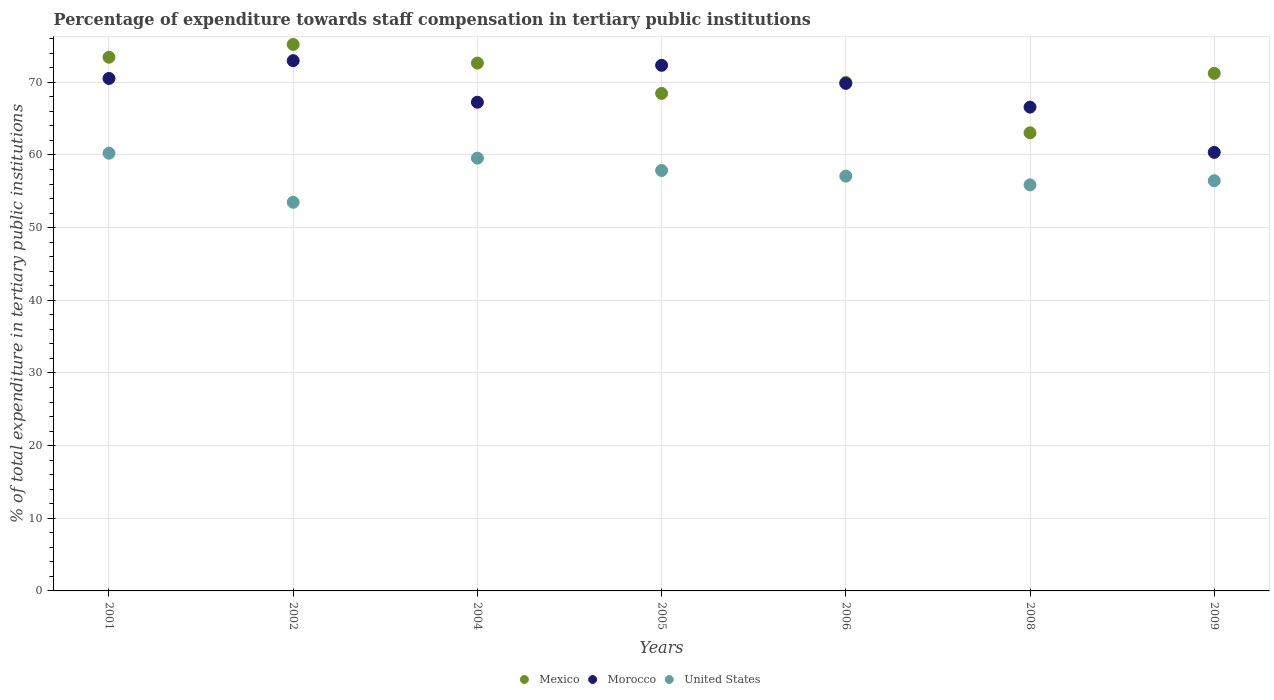What is the percentage of expenditure towards staff compensation in United States in 2009?
Your answer should be very brief. 56.46. Across all years, what is the maximum percentage of expenditure towards staff compensation in Mexico?
Offer a very short reply. 75.21. Across all years, what is the minimum percentage of expenditure towards staff compensation in United States?
Give a very brief answer. 53.49. What is the total percentage of expenditure towards staff compensation in Morocco in the graph?
Offer a terse response. 479.9. What is the difference between the percentage of expenditure towards staff compensation in United States in 2005 and that in 2006?
Make the answer very short. 0.78. What is the difference between the percentage of expenditure towards staff compensation in Mexico in 2002 and the percentage of expenditure towards staff compensation in United States in 2001?
Your answer should be very brief. 14.97. What is the average percentage of expenditure towards staff compensation in Mexico per year?
Keep it short and to the point. 70.58. In the year 2001, what is the difference between the percentage of expenditure towards staff compensation in United States and percentage of expenditure towards staff compensation in Mexico?
Make the answer very short. -13.21. In how many years, is the percentage of expenditure towards staff compensation in Mexico greater than 50 %?
Your answer should be compact. 7. What is the ratio of the percentage of expenditure towards staff compensation in Morocco in 2004 to that in 2008?
Offer a very short reply. 1.01. What is the difference between the highest and the second highest percentage of expenditure towards staff compensation in Morocco?
Provide a short and direct response. 0.64. What is the difference between the highest and the lowest percentage of expenditure towards staff compensation in United States?
Offer a terse response. 6.75. In how many years, is the percentage of expenditure towards staff compensation in Mexico greater than the average percentage of expenditure towards staff compensation in Mexico taken over all years?
Your answer should be very brief. 4. Is it the case that in every year, the sum of the percentage of expenditure towards staff compensation in United States and percentage of expenditure towards staff compensation in Mexico  is greater than the percentage of expenditure towards staff compensation in Morocco?
Your answer should be compact. Yes. Does the percentage of expenditure towards staff compensation in Morocco monotonically increase over the years?
Ensure brevity in your answer.  No. How many dotlines are there?
Keep it short and to the point. 3. How many years are there in the graph?
Provide a short and direct response. 7. Does the graph contain any zero values?
Ensure brevity in your answer.  No. Does the graph contain grids?
Provide a short and direct response. Yes. How many legend labels are there?
Provide a succinct answer. 3. What is the title of the graph?
Give a very brief answer. Percentage of expenditure towards staff compensation in tertiary public institutions. What is the label or title of the X-axis?
Make the answer very short. Years. What is the label or title of the Y-axis?
Keep it short and to the point. % of total expenditure in tertiary public institutions. What is the % of total expenditure in tertiary public institutions in Mexico in 2001?
Provide a short and direct response. 73.45. What is the % of total expenditure in tertiary public institutions of Morocco in 2001?
Provide a short and direct response. 70.53. What is the % of total expenditure in tertiary public institutions in United States in 2001?
Offer a very short reply. 60.24. What is the % of total expenditure in tertiary public institutions of Mexico in 2002?
Offer a terse response. 75.21. What is the % of total expenditure in tertiary public institutions in Morocco in 2002?
Ensure brevity in your answer.  72.98. What is the % of total expenditure in tertiary public institutions in United States in 2002?
Your answer should be compact. 53.49. What is the % of total expenditure in tertiary public institutions of Mexico in 2004?
Offer a terse response. 72.65. What is the % of total expenditure in tertiary public institutions in Morocco in 2004?
Ensure brevity in your answer.  67.26. What is the % of total expenditure in tertiary public institutions of United States in 2004?
Your answer should be compact. 59.56. What is the % of total expenditure in tertiary public institutions of Mexico in 2005?
Offer a terse response. 68.47. What is the % of total expenditure in tertiary public institutions of Morocco in 2005?
Provide a short and direct response. 72.34. What is the % of total expenditure in tertiary public institutions in United States in 2005?
Your response must be concise. 57.86. What is the % of total expenditure in tertiary public institutions of Mexico in 2006?
Ensure brevity in your answer.  69.98. What is the % of total expenditure in tertiary public institutions of Morocco in 2006?
Offer a very short reply. 69.85. What is the % of total expenditure in tertiary public institutions in United States in 2006?
Offer a terse response. 57.09. What is the % of total expenditure in tertiary public institutions of Mexico in 2008?
Offer a terse response. 63.05. What is the % of total expenditure in tertiary public institutions of Morocco in 2008?
Provide a short and direct response. 66.59. What is the % of total expenditure in tertiary public institutions in United States in 2008?
Make the answer very short. 55.88. What is the % of total expenditure in tertiary public institutions of Mexico in 2009?
Make the answer very short. 71.23. What is the % of total expenditure in tertiary public institutions in Morocco in 2009?
Your answer should be very brief. 60.36. What is the % of total expenditure in tertiary public institutions of United States in 2009?
Provide a succinct answer. 56.46. Across all years, what is the maximum % of total expenditure in tertiary public institutions of Mexico?
Offer a very short reply. 75.21. Across all years, what is the maximum % of total expenditure in tertiary public institutions in Morocco?
Your response must be concise. 72.98. Across all years, what is the maximum % of total expenditure in tertiary public institutions of United States?
Your answer should be very brief. 60.24. Across all years, what is the minimum % of total expenditure in tertiary public institutions in Mexico?
Give a very brief answer. 63.05. Across all years, what is the minimum % of total expenditure in tertiary public institutions of Morocco?
Your response must be concise. 60.36. Across all years, what is the minimum % of total expenditure in tertiary public institutions in United States?
Offer a very short reply. 53.49. What is the total % of total expenditure in tertiary public institutions of Mexico in the graph?
Make the answer very short. 494.05. What is the total % of total expenditure in tertiary public institutions of Morocco in the graph?
Your answer should be very brief. 479.9. What is the total % of total expenditure in tertiary public institutions of United States in the graph?
Your answer should be compact. 400.59. What is the difference between the % of total expenditure in tertiary public institutions of Mexico in 2001 and that in 2002?
Ensure brevity in your answer.  -1.76. What is the difference between the % of total expenditure in tertiary public institutions in Morocco in 2001 and that in 2002?
Keep it short and to the point. -2.45. What is the difference between the % of total expenditure in tertiary public institutions in United States in 2001 and that in 2002?
Offer a very short reply. 6.75. What is the difference between the % of total expenditure in tertiary public institutions in Mexico in 2001 and that in 2004?
Give a very brief answer. 0.81. What is the difference between the % of total expenditure in tertiary public institutions in Morocco in 2001 and that in 2004?
Your answer should be very brief. 3.27. What is the difference between the % of total expenditure in tertiary public institutions in United States in 2001 and that in 2004?
Keep it short and to the point. 0.68. What is the difference between the % of total expenditure in tertiary public institutions of Mexico in 2001 and that in 2005?
Your answer should be compact. 4.98. What is the difference between the % of total expenditure in tertiary public institutions in Morocco in 2001 and that in 2005?
Offer a terse response. -1.81. What is the difference between the % of total expenditure in tertiary public institutions in United States in 2001 and that in 2005?
Offer a very short reply. 2.38. What is the difference between the % of total expenditure in tertiary public institutions in Mexico in 2001 and that in 2006?
Your answer should be very brief. 3.47. What is the difference between the % of total expenditure in tertiary public institutions in Morocco in 2001 and that in 2006?
Your answer should be compact. 0.68. What is the difference between the % of total expenditure in tertiary public institutions of United States in 2001 and that in 2006?
Give a very brief answer. 3.15. What is the difference between the % of total expenditure in tertiary public institutions in Mexico in 2001 and that in 2008?
Make the answer very short. 10.4. What is the difference between the % of total expenditure in tertiary public institutions of Morocco in 2001 and that in 2008?
Provide a short and direct response. 3.95. What is the difference between the % of total expenditure in tertiary public institutions of United States in 2001 and that in 2008?
Keep it short and to the point. 4.36. What is the difference between the % of total expenditure in tertiary public institutions in Mexico in 2001 and that in 2009?
Your answer should be compact. 2.22. What is the difference between the % of total expenditure in tertiary public institutions in Morocco in 2001 and that in 2009?
Give a very brief answer. 10.18. What is the difference between the % of total expenditure in tertiary public institutions of United States in 2001 and that in 2009?
Provide a short and direct response. 3.79. What is the difference between the % of total expenditure in tertiary public institutions in Mexico in 2002 and that in 2004?
Your answer should be very brief. 2.56. What is the difference between the % of total expenditure in tertiary public institutions of Morocco in 2002 and that in 2004?
Offer a very short reply. 5.72. What is the difference between the % of total expenditure in tertiary public institutions in United States in 2002 and that in 2004?
Ensure brevity in your answer.  -6.07. What is the difference between the % of total expenditure in tertiary public institutions in Mexico in 2002 and that in 2005?
Your answer should be very brief. 6.74. What is the difference between the % of total expenditure in tertiary public institutions in Morocco in 2002 and that in 2005?
Your response must be concise. 0.64. What is the difference between the % of total expenditure in tertiary public institutions of United States in 2002 and that in 2005?
Give a very brief answer. -4.37. What is the difference between the % of total expenditure in tertiary public institutions in Mexico in 2002 and that in 2006?
Provide a succinct answer. 5.23. What is the difference between the % of total expenditure in tertiary public institutions of Morocco in 2002 and that in 2006?
Your response must be concise. 3.13. What is the difference between the % of total expenditure in tertiary public institutions in United States in 2002 and that in 2006?
Ensure brevity in your answer.  -3.6. What is the difference between the % of total expenditure in tertiary public institutions in Mexico in 2002 and that in 2008?
Ensure brevity in your answer.  12.16. What is the difference between the % of total expenditure in tertiary public institutions in Morocco in 2002 and that in 2008?
Ensure brevity in your answer.  6.39. What is the difference between the % of total expenditure in tertiary public institutions in United States in 2002 and that in 2008?
Ensure brevity in your answer.  -2.39. What is the difference between the % of total expenditure in tertiary public institutions in Mexico in 2002 and that in 2009?
Offer a terse response. 3.98. What is the difference between the % of total expenditure in tertiary public institutions in Morocco in 2002 and that in 2009?
Make the answer very short. 12.62. What is the difference between the % of total expenditure in tertiary public institutions of United States in 2002 and that in 2009?
Offer a very short reply. -2.96. What is the difference between the % of total expenditure in tertiary public institutions in Mexico in 2004 and that in 2005?
Provide a succinct answer. 4.17. What is the difference between the % of total expenditure in tertiary public institutions of Morocco in 2004 and that in 2005?
Ensure brevity in your answer.  -5.08. What is the difference between the % of total expenditure in tertiary public institutions in United States in 2004 and that in 2005?
Your response must be concise. 1.7. What is the difference between the % of total expenditure in tertiary public institutions in Mexico in 2004 and that in 2006?
Keep it short and to the point. 2.66. What is the difference between the % of total expenditure in tertiary public institutions of Morocco in 2004 and that in 2006?
Offer a very short reply. -2.59. What is the difference between the % of total expenditure in tertiary public institutions in United States in 2004 and that in 2006?
Provide a short and direct response. 2.48. What is the difference between the % of total expenditure in tertiary public institutions of Mexico in 2004 and that in 2008?
Offer a very short reply. 9.6. What is the difference between the % of total expenditure in tertiary public institutions in Morocco in 2004 and that in 2008?
Your answer should be compact. 0.67. What is the difference between the % of total expenditure in tertiary public institutions of United States in 2004 and that in 2008?
Offer a very short reply. 3.68. What is the difference between the % of total expenditure in tertiary public institutions in Mexico in 2004 and that in 2009?
Keep it short and to the point. 1.41. What is the difference between the % of total expenditure in tertiary public institutions in Morocco in 2004 and that in 2009?
Your answer should be very brief. 6.9. What is the difference between the % of total expenditure in tertiary public institutions in United States in 2004 and that in 2009?
Provide a succinct answer. 3.11. What is the difference between the % of total expenditure in tertiary public institutions in Mexico in 2005 and that in 2006?
Your answer should be compact. -1.51. What is the difference between the % of total expenditure in tertiary public institutions in Morocco in 2005 and that in 2006?
Offer a very short reply. 2.49. What is the difference between the % of total expenditure in tertiary public institutions of United States in 2005 and that in 2006?
Your answer should be very brief. 0.78. What is the difference between the % of total expenditure in tertiary public institutions of Mexico in 2005 and that in 2008?
Offer a terse response. 5.42. What is the difference between the % of total expenditure in tertiary public institutions in Morocco in 2005 and that in 2008?
Provide a succinct answer. 5.75. What is the difference between the % of total expenditure in tertiary public institutions in United States in 2005 and that in 2008?
Provide a succinct answer. 1.98. What is the difference between the % of total expenditure in tertiary public institutions of Mexico in 2005 and that in 2009?
Offer a terse response. -2.76. What is the difference between the % of total expenditure in tertiary public institutions in Morocco in 2005 and that in 2009?
Provide a short and direct response. 11.98. What is the difference between the % of total expenditure in tertiary public institutions of United States in 2005 and that in 2009?
Offer a terse response. 1.41. What is the difference between the % of total expenditure in tertiary public institutions of Mexico in 2006 and that in 2008?
Offer a terse response. 6.93. What is the difference between the % of total expenditure in tertiary public institutions in Morocco in 2006 and that in 2008?
Your answer should be very brief. 3.27. What is the difference between the % of total expenditure in tertiary public institutions in United States in 2006 and that in 2008?
Keep it short and to the point. 1.2. What is the difference between the % of total expenditure in tertiary public institutions in Mexico in 2006 and that in 2009?
Your response must be concise. -1.25. What is the difference between the % of total expenditure in tertiary public institutions of Morocco in 2006 and that in 2009?
Ensure brevity in your answer.  9.5. What is the difference between the % of total expenditure in tertiary public institutions in United States in 2006 and that in 2009?
Give a very brief answer. 0.63. What is the difference between the % of total expenditure in tertiary public institutions in Mexico in 2008 and that in 2009?
Your response must be concise. -8.18. What is the difference between the % of total expenditure in tertiary public institutions of Morocco in 2008 and that in 2009?
Offer a terse response. 6.23. What is the difference between the % of total expenditure in tertiary public institutions of United States in 2008 and that in 2009?
Your answer should be compact. -0.57. What is the difference between the % of total expenditure in tertiary public institutions in Mexico in 2001 and the % of total expenditure in tertiary public institutions in Morocco in 2002?
Your answer should be compact. 0.47. What is the difference between the % of total expenditure in tertiary public institutions of Mexico in 2001 and the % of total expenditure in tertiary public institutions of United States in 2002?
Offer a very short reply. 19.96. What is the difference between the % of total expenditure in tertiary public institutions of Morocco in 2001 and the % of total expenditure in tertiary public institutions of United States in 2002?
Offer a terse response. 17.04. What is the difference between the % of total expenditure in tertiary public institutions in Mexico in 2001 and the % of total expenditure in tertiary public institutions in Morocco in 2004?
Offer a very short reply. 6.19. What is the difference between the % of total expenditure in tertiary public institutions in Mexico in 2001 and the % of total expenditure in tertiary public institutions in United States in 2004?
Provide a succinct answer. 13.89. What is the difference between the % of total expenditure in tertiary public institutions of Morocco in 2001 and the % of total expenditure in tertiary public institutions of United States in 2004?
Provide a succinct answer. 10.97. What is the difference between the % of total expenditure in tertiary public institutions in Mexico in 2001 and the % of total expenditure in tertiary public institutions in Morocco in 2005?
Provide a short and direct response. 1.11. What is the difference between the % of total expenditure in tertiary public institutions in Mexico in 2001 and the % of total expenditure in tertiary public institutions in United States in 2005?
Offer a terse response. 15.59. What is the difference between the % of total expenditure in tertiary public institutions of Morocco in 2001 and the % of total expenditure in tertiary public institutions of United States in 2005?
Offer a terse response. 12.67. What is the difference between the % of total expenditure in tertiary public institutions of Mexico in 2001 and the % of total expenditure in tertiary public institutions of Morocco in 2006?
Make the answer very short. 3.6. What is the difference between the % of total expenditure in tertiary public institutions of Mexico in 2001 and the % of total expenditure in tertiary public institutions of United States in 2006?
Ensure brevity in your answer.  16.36. What is the difference between the % of total expenditure in tertiary public institutions of Morocco in 2001 and the % of total expenditure in tertiary public institutions of United States in 2006?
Your answer should be compact. 13.44. What is the difference between the % of total expenditure in tertiary public institutions of Mexico in 2001 and the % of total expenditure in tertiary public institutions of Morocco in 2008?
Make the answer very short. 6.87. What is the difference between the % of total expenditure in tertiary public institutions of Mexico in 2001 and the % of total expenditure in tertiary public institutions of United States in 2008?
Provide a short and direct response. 17.57. What is the difference between the % of total expenditure in tertiary public institutions in Morocco in 2001 and the % of total expenditure in tertiary public institutions in United States in 2008?
Give a very brief answer. 14.65. What is the difference between the % of total expenditure in tertiary public institutions of Mexico in 2001 and the % of total expenditure in tertiary public institutions of Morocco in 2009?
Your response must be concise. 13.1. What is the difference between the % of total expenditure in tertiary public institutions in Mexico in 2001 and the % of total expenditure in tertiary public institutions in United States in 2009?
Your answer should be very brief. 17. What is the difference between the % of total expenditure in tertiary public institutions of Morocco in 2001 and the % of total expenditure in tertiary public institutions of United States in 2009?
Your response must be concise. 14.08. What is the difference between the % of total expenditure in tertiary public institutions in Mexico in 2002 and the % of total expenditure in tertiary public institutions in Morocco in 2004?
Your answer should be compact. 7.95. What is the difference between the % of total expenditure in tertiary public institutions in Mexico in 2002 and the % of total expenditure in tertiary public institutions in United States in 2004?
Provide a succinct answer. 15.64. What is the difference between the % of total expenditure in tertiary public institutions of Morocco in 2002 and the % of total expenditure in tertiary public institutions of United States in 2004?
Keep it short and to the point. 13.41. What is the difference between the % of total expenditure in tertiary public institutions of Mexico in 2002 and the % of total expenditure in tertiary public institutions of Morocco in 2005?
Offer a terse response. 2.87. What is the difference between the % of total expenditure in tertiary public institutions in Mexico in 2002 and the % of total expenditure in tertiary public institutions in United States in 2005?
Offer a very short reply. 17.34. What is the difference between the % of total expenditure in tertiary public institutions of Morocco in 2002 and the % of total expenditure in tertiary public institutions of United States in 2005?
Offer a terse response. 15.11. What is the difference between the % of total expenditure in tertiary public institutions in Mexico in 2002 and the % of total expenditure in tertiary public institutions in Morocco in 2006?
Keep it short and to the point. 5.36. What is the difference between the % of total expenditure in tertiary public institutions in Mexico in 2002 and the % of total expenditure in tertiary public institutions in United States in 2006?
Your answer should be compact. 18.12. What is the difference between the % of total expenditure in tertiary public institutions in Morocco in 2002 and the % of total expenditure in tertiary public institutions in United States in 2006?
Give a very brief answer. 15.89. What is the difference between the % of total expenditure in tertiary public institutions in Mexico in 2002 and the % of total expenditure in tertiary public institutions in Morocco in 2008?
Your answer should be very brief. 8.62. What is the difference between the % of total expenditure in tertiary public institutions in Mexico in 2002 and the % of total expenditure in tertiary public institutions in United States in 2008?
Give a very brief answer. 19.32. What is the difference between the % of total expenditure in tertiary public institutions of Morocco in 2002 and the % of total expenditure in tertiary public institutions of United States in 2008?
Make the answer very short. 17.09. What is the difference between the % of total expenditure in tertiary public institutions in Mexico in 2002 and the % of total expenditure in tertiary public institutions in Morocco in 2009?
Offer a very short reply. 14.85. What is the difference between the % of total expenditure in tertiary public institutions in Mexico in 2002 and the % of total expenditure in tertiary public institutions in United States in 2009?
Make the answer very short. 18.75. What is the difference between the % of total expenditure in tertiary public institutions of Morocco in 2002 and the % of total expenditure in tertiary public institutions of United States in 2009?
Offer a terse response. 16.52. What is the difference between the % of total expenditure in tertiary public institutions in Mexico in 2004 and the % of total expenditure in tertiary public institutions in Morocco in 2005?
Your answer should be very brief. 0.31. What is the difference between the % of total expenditure in tertiary public institutions in Mexico in 2004 and the % of total expenditure in tertiary public institutions in United States in 2005?
Give a very brief answer. 14.78. What is the difference between the % of total expenditure in tertiary public institutions of Morocco in 2004 and the % of total expenditure in tertiary public institutions of United States in 2005?
Your answer should be compact. 9.4. What is the difference between the % of total expenditure in tertiary public institutions in Mexico in 2004 and the % of total expenditure in tertiary public institutions in Morocco in 2006?
Ensure brevity in your answer.  2.79. What is the difference between the % of total expenditure in tertiary public institutions of Mexico in 2004 and the % of total expenditure in tertiary public institutions of United States in 2006?
Provide a succinct answer. 15.56. What is the difference between the % of total expenditure in tertiary public institutions of Morocco in 2004 and the % of total expenditure in tertiary public institutions of United States in 2006?
Provide a succinct answer. 10.17. What is the difference between the % of total expenditure in tertiary public institutions of Mexico in 2004 and the % of total expenditure in tertiary public institutions of Morocco in 2008?
Your answer should be compact. 6.06. What is the difference between the % of total expenditure in tertiary public institutions of Mexico in 2004 and the % of total expenditure in tertiary public institutions of United States in 2008?
Your response must be concise. 16.76. What is the difference between the % of total expenditure in tertiary public institutions in Morocco in 2004 and the % of total expenditure in tertiary public institutions in United States in 2008?
Your answer should be compact. 11.37. What is the difference between the % of total expenditure in tertiary public institutions in Mexico in 2004 and the % of total expenditure in tertiary public institutions in Morocco in 2009?
Your answer should be compact. 12.29. What is the difference between the % of total expenditure in tertiary public institutions in Mexico in 2004 and the % of total expenditure in tertiary public institutions in United States in 2009?
Make the answer very short. 16.19. What is the difference between the % of total expenditure in tertiary public institutions of Morocco in 2004 and the % of total expenditure in tertiary public institutions of United States in 2009?
Your answer should be very brief. 10.8. What is the difference between the % of total expenditure in tertiary public institutions of Mexico in 2005 and the % of total expenditure in tertiary public institutions of Morocco in 2006?
Keep it short and to the point. -1.38. What is the difference between the % of total expenditure in tertiary public institutions of Mexico in 2005 and the % of total expenditure in tertiary public institutions of United States in 2006?
Give a very brief answer. 11.39. What is the difference between the % of total expenditure in tertiary public institutions in Morocco in 2005 and the % of total expenditure in tertiary public institutions in United States in 2006?
Your answer should be very brief. 15.25. What is the difference between the % of total expenditure in tertiary public institutions in Mexico in 2005 and the % of total expenditure in tertiary public institutions in Morocco in 2008?
Offer a terse response. 1.89. What is the difference between the % of total expenditure in tertiary public institutions of Mexico in 2005 and the % of total expenditure in tertiary public institutions of United States in 2008?
Keep it short and to the point. 12.59. What is the difference between the % of total expenditure in tertiary public institutions of Morocco in 2005 and the % of total expenditure in tertiary public institutions of United States in 2008?
Keep it short and to the point. 16.45. What is the difference between the % of total expenditure in tertiary public institutions in Mexico in 2005 and the % of total expenditure in tertiary public institutions in Morocco in 2009?
Ensure brevity in your answer.  8.12. What is the difference between the % of total expenditure in tertiary public institutions in Mexico in 2005 and the % of total expenditure in tertiary public institutions in United States in 2009?
Provide a succinct answer. 12.02. What is the difference between the % of total expenditure in tertiary public institutions in Morocco in 2005 and the % of total expenditure in tertiary public institutions in United States in 2009?
Offer a terse response. 15.88. What is the difference between the % of total expenditure in tertiary public institutions of Mexico in 2006 and the % of total expenditure in tertiary public institutions of Morocco in 2008?
Offer a terse response. 3.4. What is the difference between the % of total expenditure in tertiary public institutions in Mexico in 2006 and the % of total expenditure in tertiary public institutions in United States in 2008?
Keep it short and to the point. 14.1. What is the difference between the % of total expenditure in tertiary public institutions in Morocco in 2006 and the % of total expenditure in tertiary public institutions in United States in 2008?
Offer a terse response. 13.97. What is the difference between the % of total expenditure in tertiary public institutions in Mexico in 2006 and the % of total expenditure in tertiary public institutions in Morocco in 2009?
Offer a terse response. 9.63. What is the difference between the % of total expenditure in tertiary public institutions of Mexico in 2006 and the % of total expenditure in tertiary public institutions of United States in 2009?
Provide a short and direct response. 13.53. What is the difference between the % of total expenditure in tertiary public institutions in Morocco in 2006 and the % of total expenditure in tertiary public institutions in United States in 2009?
Keep it short and to the point. 13.4. What is the difference between the % of total expenditure in tertiary public institutions in Mexico in 2008 and the % of total expenditure in tertiary public institutions in Morocco in 2009?
Your answer should be compact. 2.69. What is the difference between the % of total expenditure in tertiary public institutions in Mexico in 2008 and the % of total expenditure in tertiary public institutions in United States in 2009?
Keep it short and to the point. 6.59. What is the difference between the % of total expenditure in tertiary public institutions in Morocco in 2008 and the % of total expenditure in tertiary public institutions in United States in 2009?
Offer a terse response. 10.13. What is the average % of total expenditure in tertiary public institutions of Mexico per year?
Your response must be concise. 70.58. What is the average % of total expenditure in tertiary public institutions in Morocco per year?
Your answer should be compact. 68.56. What is the average % of total expenditure in tertiary public institutions in United States per year?
Offer a very short reply. 57.23. In the year 2001, what is the difference between the % of total expenditure in tertiary public institutions of Mexico and % of total expenditure in tertiary public institutions of Morocco?
Your response must be concise. 2.92. In the year 2001, what is the difference between the % of total expenditure in tertiary public institutions of Mexico and % of total expenditure in tertiary public institutions of United States?
Your response must be concise. 13.21. In the year 2001, what is the difference between the % of total expenditure in tertiary public institutions in Morocco and % of total expenditure in tertiary public institutions in United States?
Ensure brevity in your answer.  10.29. In the year 2002, what is the difference between the % of total expenditure in tertiary public institutions of Mexico and % of total expenditure in tertiary public institutions of Morocco?
Your answer should be compact. 2.23. In the year 2002, what is the difference between the % of total expenditure in tertiary public institutions in Mexico and % of total expenditure in tertiary public institutions in United States?
Make the answer very short. 21.72. In the year 2002, what is the difference between the % of total expenditure in tertiary public institutions of Morocco and % of total expenditure in tertiary public institutions of United States?
Ensure brevity in your answer.  19.49. In the year 2004, what is the difference between the % of total expenditure in tertiary public institutions of Mexico and % of total expenditure in tertiary public institutions of Morocco?
Your answer should be very brief. 5.39. In the year 2004, what is the difference between the % of total expenditure in tertiary public institutions in Mexico and % of total expenditure in tertiary public institutions in United States?
Ensure brevity in your answer.  13.08. In the year 2004, what is the difference between the % of total expenditure in tertiary public institutions in Morocco and % of total expenditure in tertiary public institutions in United States?
Provide a short and direct response. 7.69. In the year 2005, what is the difference between the % of total expenditure in tertiary public institutions of Mexico and % of total expenditure in tertiary public institutions of Morocco?
Make the answer very short. -3.87. In the year 2005, what is the difference between the % of total expenditure in tertiary public institutions in Mexico and % of total expenditure in tertiary public institutions in United States?
Keep it short and to the point. 10.61. In the year 2005, what is the difference between the % of total expenditure in tertiary public institutions in Morocco and % of total expenditure in tertiary public institutions in United States?
Keep it short and to the point. 14.47. In the year 2006, what is the difference between the % of total expenditure in tertiary public institutions of Mexico and % of total expenditure in tertiary public institutions of Morocco?
Give a very brief answer. 0.13. In the year 2006, what is the difference between the % of total expenditure in tertiary public institutions in Mexico and % of total expenditure in tertiary public institutions in United States?
Your answer should be very brief. 12.9. In the year 2006, what is the difference between the % of total expenditure in tertiary public institutions in Morocco and % of total expenditure in tertiary public institutions in United States?
Your answer should be very brief. 12.76. In the year 2008, what is the difference between the % of total expenditure in tertiary public institutions of Mexico and % of total expenditure in tertiary public institutions of Morocco?
Your answer should be compact. -3.54. In the year 2008, what is the difference between the % of total expenditure in tertiary public institutions in Mexico and % of total expenditure in tertiary public institutions in United States?
Your answer should be compact. 7.16. In the year 2008, what is the difference between the % of total expenditure in tertiary public institutions in Morocco and % of total expenditure in tertiary public institutions in United States?
Make the answer very short. 10.7. In the year 2009, what is the difference between the % of total expenditure in tertiary public institutions of Mexico and % of total expenditure in tertiary public institutions of Morocco?
Your response must be concise. 10.88. In the year 2009, what is the difference between the % of total expenditure in tertiary public institutions of Mexico and % of total expenditure in tertiary public institutions of United States?
Make the answer very short. 14.78. In the year 2009, what is the difference between the % of total expenditure in tertiary public institutions of Morocco and % of total expenditure in tertiary public institutions of United States?
Keep it short and to the point. 3.9. What is the ratio of the % of total expenditure in tertiary public institutions of Mexico in 2001 to that in 2002?
Your answer should be compact. 0.98. What is the ratio of the % of total expenditure in tertiary public institutions of Morocco in 2001 to that in 2002?
Give a very brief answer. 0.97. What is the ratio of the % of total expenditure in tertiary public institutions of United States in 2001 to that in 2002?
Ensure brevity in your answer.  1.13. What is the ratio of the % of total expenditure in tertiary public institutions of Mexico in 2001 to that in 2004?
Provide a succinct answer. 1.01. What is the ratio of the % of total expenditure in tertiary public institutions in Morocco in 2001 to that in 2004?
Your answer should be compact. 1.05. What is the ratio of the % of total expenditure in tertiary public institutions in United States in 2001 to that in 2004?
Your answer should be very brief. 1.01. What is the ratio of the % of total expenditure in tertiary public institutions of Mexico in 2001 to that in 2005?
Your answer should be very brief. 1.07. What is the ratio of the % of total expenditure in tertiary public institutions in Morocco in 2001 to that in 2005?
Make the answer very short. 0.97. What is the ratio of the % of total expenditure in tertiary public institutions in United States in 2001 to that in 2005?
Provide a succinct answer. 1.04. What is the ratio of the % of total expenditure in tertiary public institutions in Mexico in 2001 to that in 2006?
Give a very brief answer. 1.05. What is the ratio of the % of total expenditure in tertiary public institutions of Morocco in 2001 to that in 2006?
Provide a succinct answer. 1.01. What is the ratio of the % of total expenditure in tertiary public institutions in United States in 2001 to that in 2006?
Ensure brevity in your answer.  1.06. What is the ratio of the % of total expenditure in tertiary public institutions of Mexico in 2001 to that in 2008?
Provide a succinct answer. 1.17. What is the ratio of the % of total expenditure in tertiary public institutions of Morocco in 2001 to that in 2008?
Provide a short and direct response. 1.06. What is the ratio of the % of total expenditure in tertiary public institutions of United States in 2001 to that in 2008?
Give a very brief answer. 1.08. What is the ratio of the % of total expenditure in tertiary public institutions of Mexico in 2001 to that in 2009?
Your response must be concise. 1.03. What is the ratio of the % of total expenditure in tertiary public institutions of Morocco in 2001 to that in 2009?
Your answer should be very brief. 1.17. What is the ratio of the % of total expenditure in tertiary public institutions of United States in 2001 to that in 2009?
Your answer should be compact. 1.07. What is the ratio of the % of total expenditure in tertiary public institutions of Mexico in 2002 to that in 2004?
Provide a short and direct response. 1.04. What is the ratio of the % of total expenditure in tertiary public institutions in Morocco in 2002 to that in 2004?
Make the answer very short. 1.08. What is the ratio of the % of total expenditure in tertiary public institutions of United States in 2002 to that in 2004?
Make the answer very short. 0.9. What is the ratio of the % of total expenditure in tertiary public institutions of Mexico in 2002 to that in 2005?
Keep it short and to the point. 1.1. What is the ratio of the % of total expenditure in tertiary public institutions of Morocco in 2002 to that in 2005?
Offer a terse response. 1.01. What is the ratio of the % of total expenditure in tertiary public institutions in United States in 2002 to that in 2005?
Give a very brief answer. 0.92. What is the ratio of the % of total expenditure in tertiary public institutions in Mexico in 2002 to that in 2006?
Keep it short and to the point. 1.07. What is the ratio of the % of total expenditure in tertiary public institutions in Morocco in 2002 to that in 2006?
Offer a terse response. 1.04. What is the ratio of the % of total expenditure in tertiary public institutions in United States in 2002 to that in 2006?
Give a very brief answer. 0.94. What is the ratio of the % of total expenditure in tertiary public institutions in Mexico in 2002 to that in 2008?
Make the answer very short. 1.19. What is the ratio of the % of total expenditure in tertiary public institutions of Morocco in 2002 to that in 2008?
Your answer should be compact. 1.1. What is the ratio of the % of total expenditure in tertiary public institutions of United States in 2002 to that in 2008?
Give a very brief answer. 0.96. What is the ratio of the % of total expenditure in tertiary public institutions of Mexico in 2002 to that in 2009?
Give a very brief answer. 1.06. What is the ratio of the % of total expenditure in tertiary public institutions in Morocco in 2002 to that in 2009?
Offer a very short reply. 1.21. What is the ratio of the % of total expenditure in tertiary public institutions in United States in 2002 to that in 2009?
Your answer should be very brief. 0.95. What is the ratio of the % of total expenditure in tertiary public institutions in Mexico in 2004 to that in 2005?
Make the answer very short. 1.06. What is the ratio of the % of total expenditure in tertiary public institutions of Morocco in 2004 to that in 2005?
Give a very brief answer. 0.93. What is the ratio of the % of total expenditure in tertiary public institutions in United States in 2004 to that in 2005?
Make the answer very short. 1.03. What is the ratio of the % of total expenditure in tertiary public institutions of Mexico in 2004 to that in 2006?
Make the answer very short. 1.04. What is the ratio of the % of total expenditure in tertiary public institutions of Morocco in 2004 to that in 2006?
Provide a succinct answer. 0.96. What is the ratio of the % of total expenditure in tertiary public institutions of United States in 2004 to that in 2006?
Offer a very short reply. 1.04. What is the ratio of the % of total expenditure in tertiary public institutions of Mexico in 2004 to that in 2008?
Provide a succinct answer. 1.15. What is the ratio of the % of total expenditure in tertiary public institutions in Morocco in 2004 to that in 2008?
Make the answer very short. 1.01. What is the ratio of the % of total expenditure in tertiary public institutions of United States in 2004 to that in 2008?
Make the answer very short. 1.07. What is the ratio of the % of total expenditure in tertiary public institutions in Mexico in 2004 to that in 2009?
Keep it short and to the point. 1.02. What is the ratio of the % of total expenditure in tertiary public institutions in Morocco in 2004 to that in 2009?
Your answer should be very brief. 1.11. What is the ratio of the % of total expenditure in tertiary public institutions in United States in 2004 to that in 2009?
Provide a short and direct response. 1.06. What is the ratio of the % of total expenditure in tertiary public institutions in Mexico in 2005 to that in 2006?
Make the answer very short. 0.98. What is the ratio of the % of total expenditure in tertiary public institutions of Morocco in 2005 to that in 2006?
Make the answer very short. 1.04. What is the ratio of the % of total expenditure in tertiary public institutions in United States in 2005 to that in 2006?
Provide a short and direct response. 1.01. What is the ratio of the % of total expenditure in tertiary public institutions of Mexico in 2005 to that in 2008?
Your response must be concise. 1.09. What is the ratio of the % of total expenditure in tertiary public institutions in Morocco in 2005 to that in 2008?
Provide a succinct answer. 1.09. What is the ratio of the % of total expenditure in tertiary public institutions in United States in 2005 to that in 2008?
Give a very brief answer. 1.04. What is the ratio of the % of total expenditure in tertiary public institutions in Mexico in 2005 to that in 2009?
Provide a succinct answer. 0.96. What is the ratio of the % of total expenditure in tertiary public institutions of Morocco in 2005 to that in 2009?
Keep it short and to the point. 1.2. What is the ratio of the % of total expenditure in tertiary public institutions of United States in 2005 to that in 2009?
Your answer should be compact. 1.02. What is the ratio of the % of total expenditure in tertiary public institutions of Mexico in 2006 to that in 2008?
Keep it short and to the point. 1.11. What is the ratio of the % of total expenditure in tertiary public institutions in Morocco in 2006 to that in 2008?
Offer a very short reply. 1.05. What is the ratio of the % of total expenditure in tertiary public institutions of United States in 2006 to that in 2008?
Your answer should be compact. 1.02. What is the ratio of the % of total expenditure in tertiary public institutions of Mexico in 2006 to that in 2009?
Give a very brief answer. 0.98. What is the ratio of the % of total expenditure in tertiary public institutions of Morocco in 2006 to that in 2009?
Your answer should be compact. 1.16. What is the ratio of the % of total expenditure in tertiary public institutions of United States in 2006 to that in 2009?
Your response must be concise. 1.01. What is the ratio of the % of total expenditure in tertiary public institutions in Mexico in 2008 to that in 2009?
Make the answer very short. 0.89. What is the ratio of the % of total expenditure in tertiary public institutions in Morocco in 2008 to that in 2009?
Ensure brevity in your answer.  1.1. What is the difference between the highest and the second highest % of total expenditure in tertiary public institutions of Mexico?
Offer a terse response. 1.76. What is the difference between the highest and the second highest % of total expenditure in tertiary public institutions of Morocco?
Your answer should be compact. 0.64. What is the difference between the highest and the second highest % of total expenditure in tertiary public institutions in United States?
Keep it short and to the point. 0.68. What is the difference between the highest and the lowest % of total expenditure in tertiary public institutions of Mexico?
Make the answer very short. 12.16. What is the difference between the highest and the lowest % of total expenditure in tertiary public institutions in Morocco?
Provide a short and direct response. 12.62. What is the difference between the highest and the lowest % of total expenditure in tertiary public institutions of United States?
Provide a succinct answer. 6.75. 